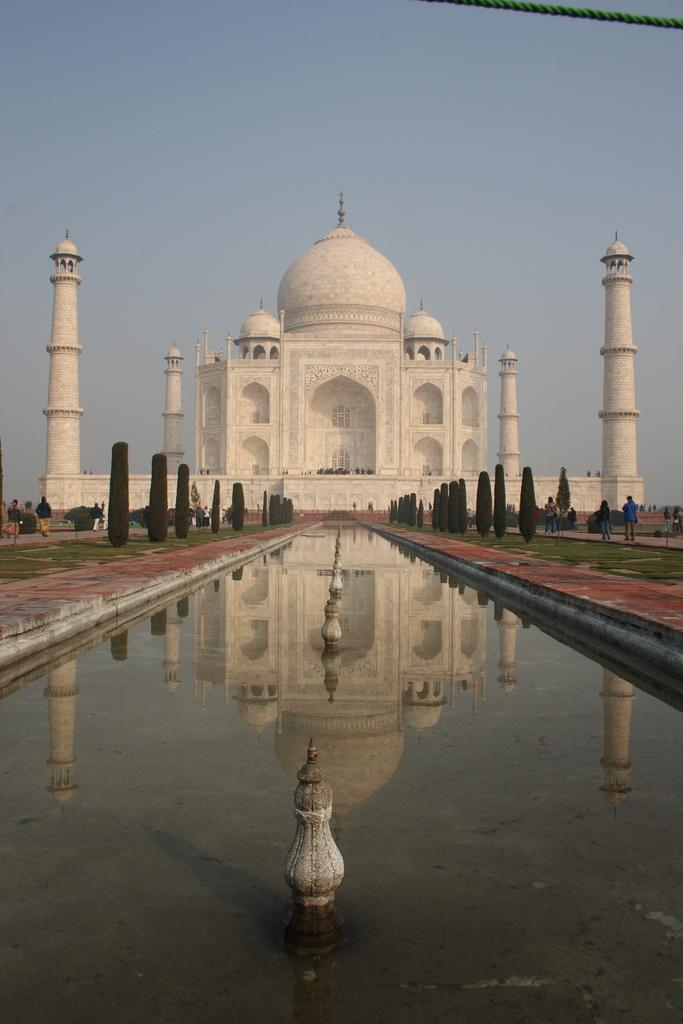What is the color of the Taj Mahal in the image? The Taj Mahal is white in color. What is located near the Taj Mahal in the image? There is a small water canal near the Taj Mahal. What type of vegetation can be seen in the image? There are plants visible in the image. What is the color of the sky in the image? The sky is blue in color. What type of calculator is being used to measure the height of the Taj Mahal in the image? There is no calculator present in the image, and the height of the Taj Mahal is not being measured. 